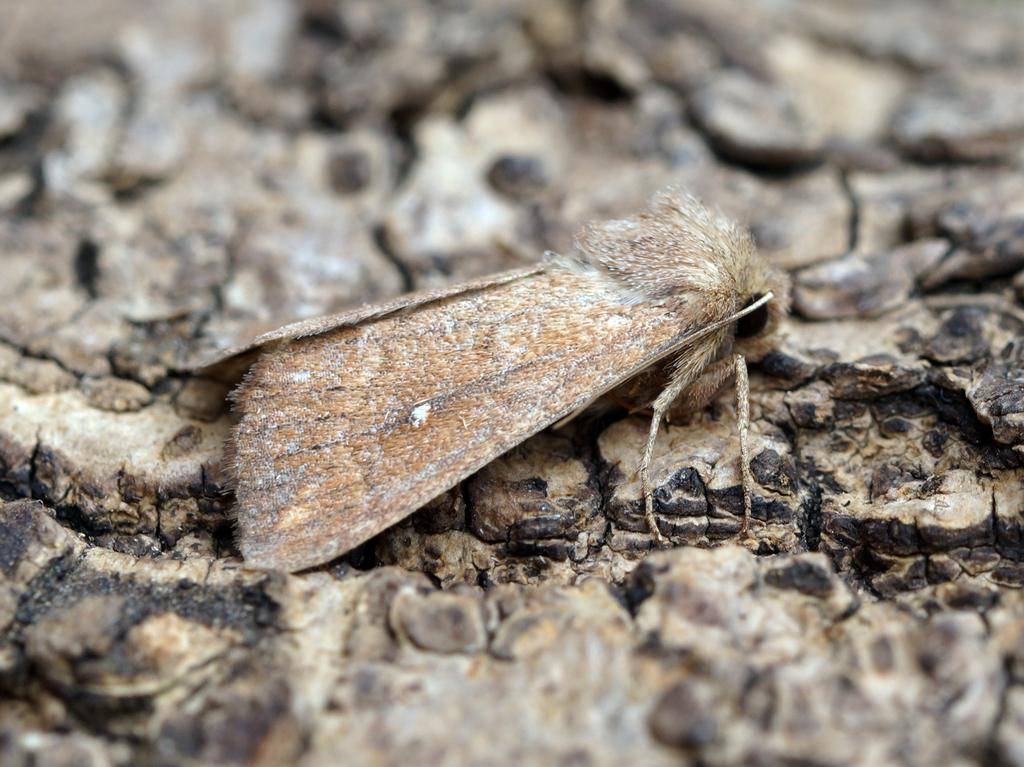What type of creature is present in the image? There is an insect in the image. Where is the insect located? The insect is on the bark of a tree. What type of power source can be seen near the seashore in the image? There is no power source or seashore present in the image; it features an insect on the bark of a tree. What type of crops are growing in the field in the image? There is no field or crops present in the image; it features an insect on the bark of a tree. 